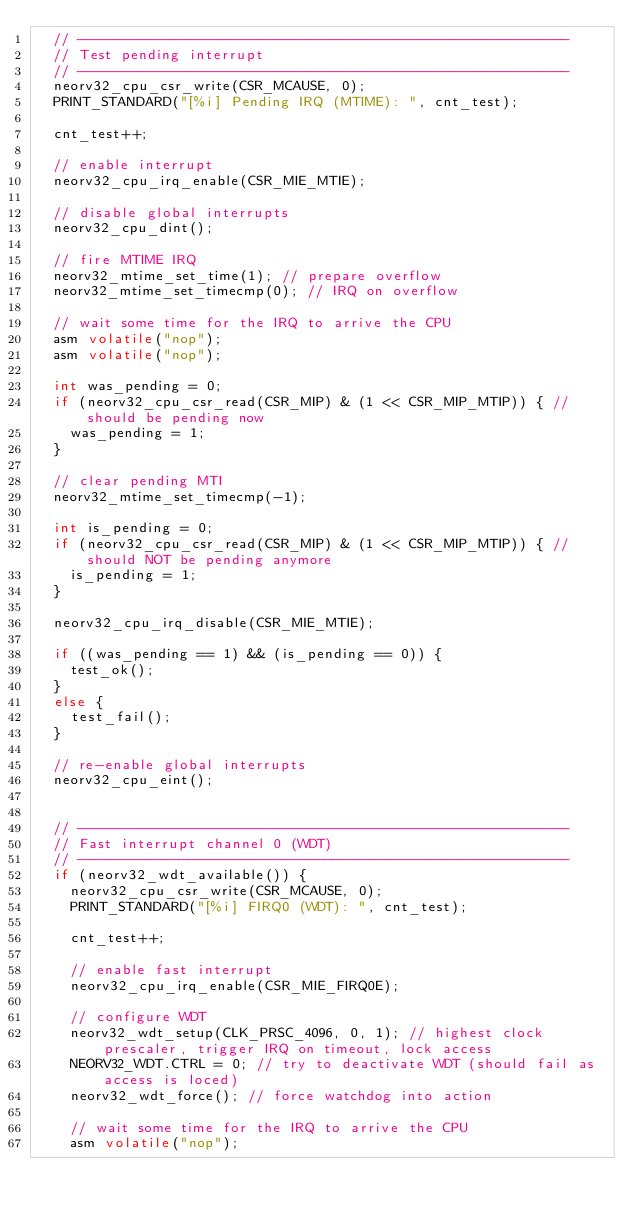<code> <loc_0><loc_0><loc_500><loc_500><_C_>  // ----------------------------------------------------------
  // Test pending interrupt
  // ----------------------------------------------------------
  neorv32_cpu_csr_write(CSR_MCAUSE, 0);
  PRINT_STANDARD("[%i] Pending IRQ (MTIME): ", cnt_test);

  cnt_test++;

  // enable interrupt
  neorv32_cpu_irq_enable(CSR_MIE_MTIE);

  // disable global interrupts
  neorv32_cpu_dint();

  // fire MTIME IRQ
  neorv32_mtime_set_time(1); // prepare overflow
  neorv32_mtime_set_timecmp(0); // IRQ on overflow

  // wait some time for the IRQ to arrive the CPU
  asm volatile("nop");
  asm volatile("nop");

  int was_pending = 0;
  if (neorv32_cpu_csr_read(CSR_MIP) & (1 << CSR_MIP_MTIP)) { // should be pending now
    was_pending = 1;
  }

  // clear pending MTI
  neorv32_mtime_set_timecmp(-1);

  int is_pending = 0;
  if (neorv32_cpu_csr_read(CSR_MIP) & (1 << CSR_MIP_MTIP)) { // should NOT be pending anymore
    is_pending = 1;
  }

  neorv32_cpu_irq_disable(CSR_MIE_MTIE);

  if ((was_pending == 1) && (is_pending == 0)) {
    test_ok();
  }
  else {
    test_fail();
  }

  // re-enable global interrupts
  neorv32_cpu_eint();


  // ----------------------------------------------------------
  // Fast interrupt channel 0 (WDT)
  // ----------------------------------------------------------
  if (neorv32_wdt_available()) {
    neorv32_cpu_csr_write(CSR_MCAUSE, 0);
    PRINT_STANDARD("[%i] FIRQ0 (WDT): ", cnt_test);

    cnt_test++;

    // enable fast interrupt
    neorv32_cpu_irq_enable(CSR_MIE_FIRQ0E);

    // configure WDT
    neorv32_wdt_setup(CLK_PRSC_4096, 0, 1); // highest clock prescaler, trigger IRQ on timeout, lock access
    NEORV32_WDT.CTRL = 0; // try to deactivate WDT (should fail as access is loced)
    neorv32_wdt_force(); // force watchdog into action

    // wait some time for the IRQ to arrive the CPU
    asm volatile("nop");</code> 